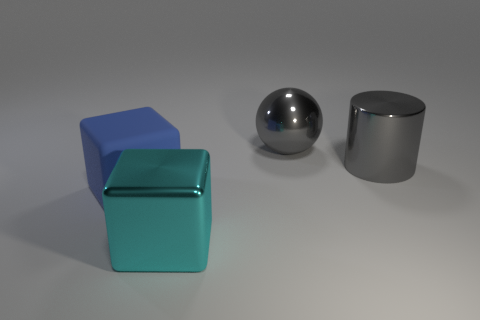If these objects were part of a physics experiment, which one would you say has the highest potential energy? If we're considering gravitational potential energy and assuming they're at the same elevation, potential energy cannot be determined from visual information alone. However, if their placement height differs, the object highest from the ground level—the blue cube—would typically have the highest potential energy. 